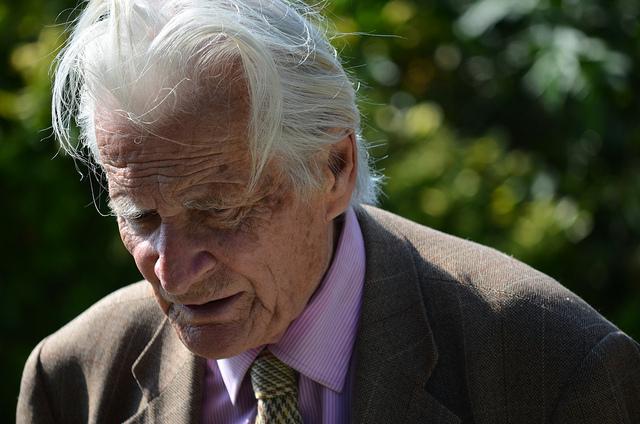Is this man young?
Keep it brief. No. What color is his hair?
Be succinct. White. How is this man's posture?
Be succinct. Stopped. 